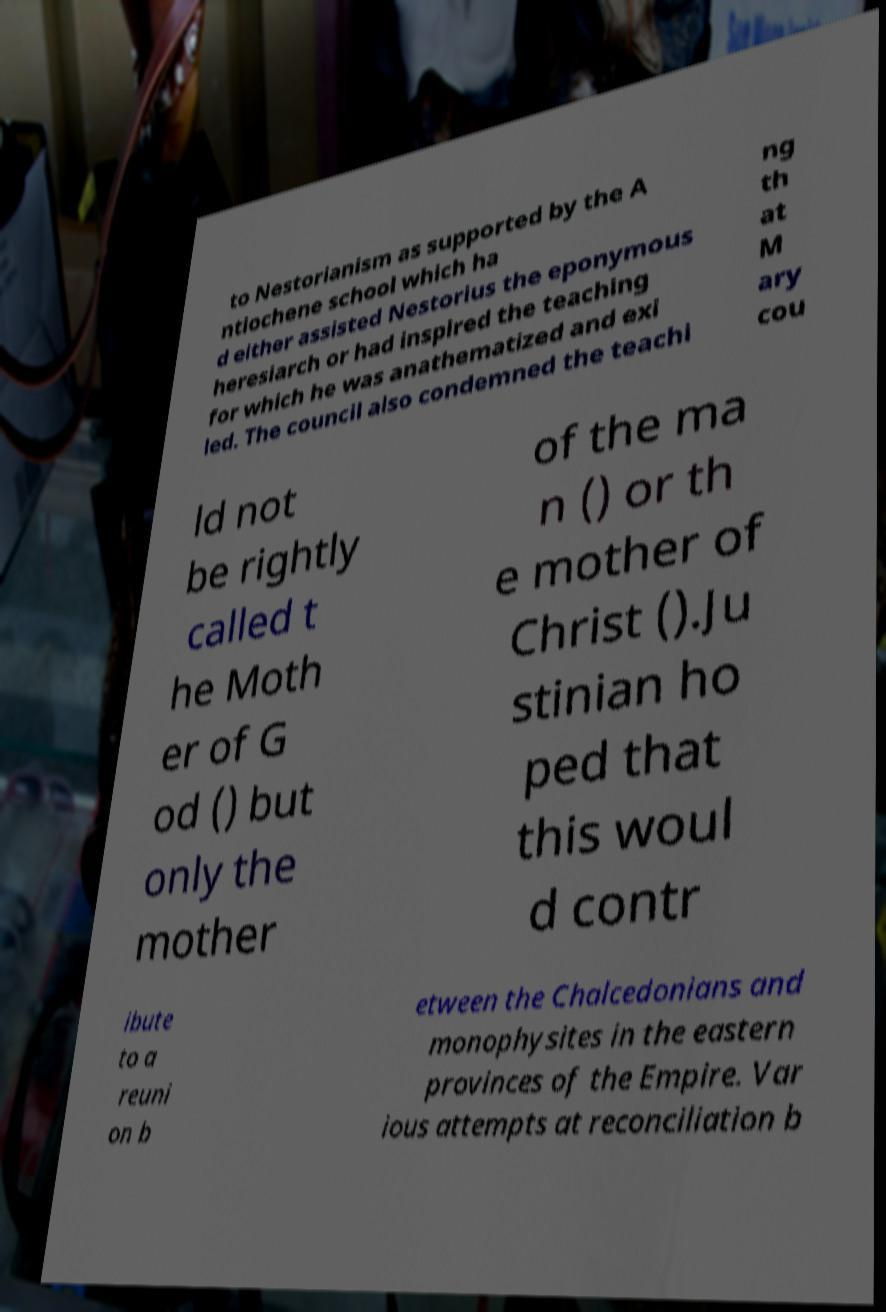Could you assist in decoding the text presented in this image and type it out clearly? to Nestorianism as supported by the A ntiochene school which ha d either assisted Nestorius the eponymous heresiarch or had inspired the teaching for which he was anathematized and exi led. The council also condemned the teachi ng th at M ary cou ld not be rightly called t he Moth er of G od () but only the mother of the ma n () or th e mother of Christ ().Ju stinian ho ped that this woul d contr ibute to a reuni on b etween the Chalcedonians and monophysites in the eastern provinces of the Empire. Var ious attempts at reconciliation b 